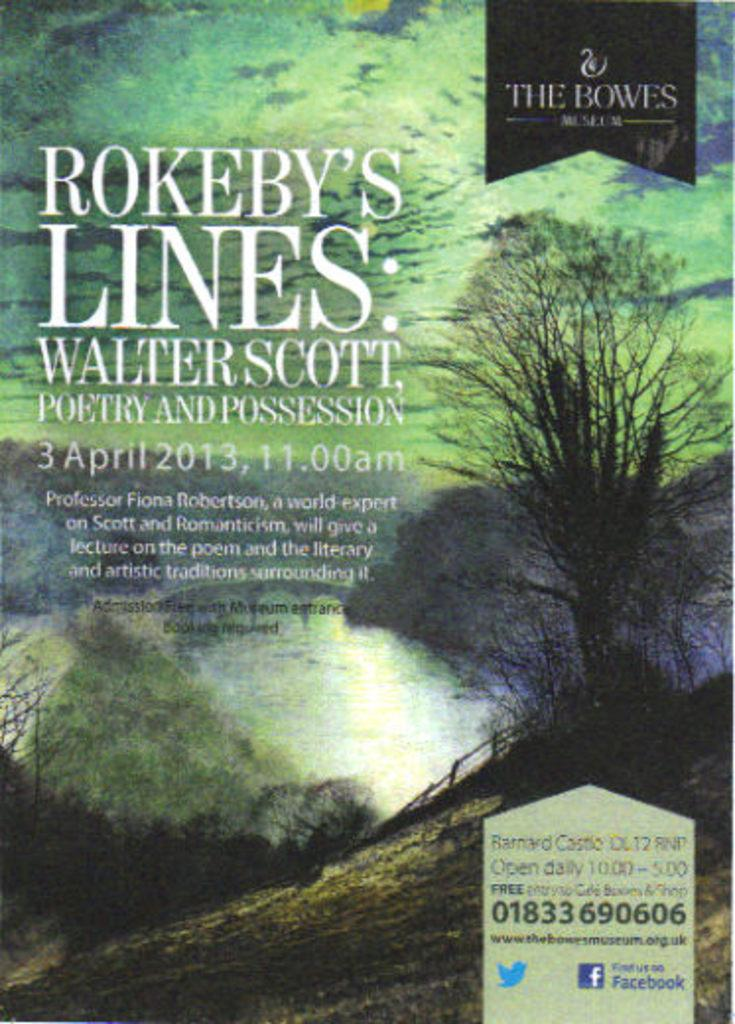<image>
Write a terse but informative summary of the picture. a book called rokeby's lines about poetry from 2013 